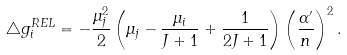Convert formula to latex. <formula><loc_0><loc_0><loc_500><loc_500>\bigtriangleup g _ { i } ^ { R E L } = - \frac { \mu _ { j } ^ { 2 } } { 2 } \left ( \mu _ { j } - \frac { \mu _ { i } } { J + 1 } + \frac { 1 } { 2 J + 1 } \right ) \left ( \frac { \alpha ^ { \prime } } { n } \right ) ^ { 2 } .</formula> 